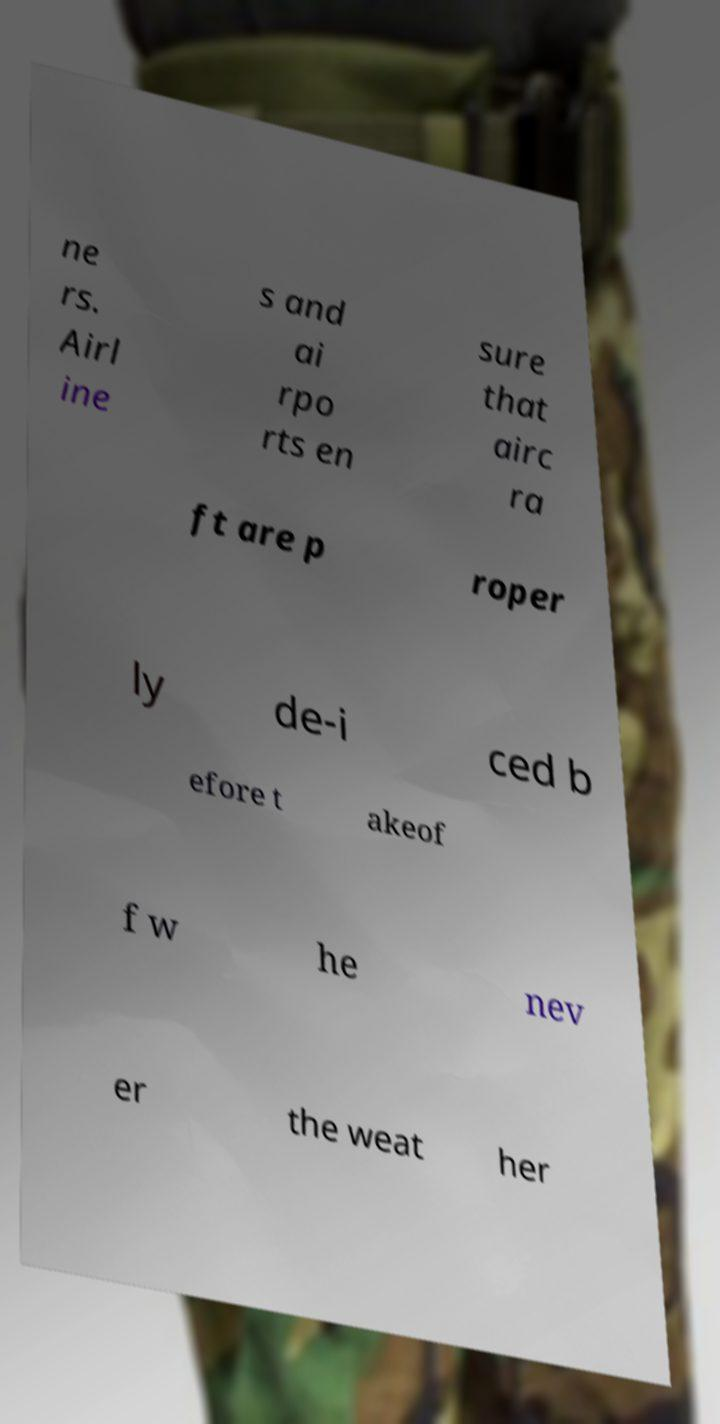Could you assist in decoding the text presented in this image and type it out clearly? ne rs. Airl ine s and ai rpo rts en sure that airc ra ft are p roper ly de-i ced b efore t akeof f w he nev er the weat her 